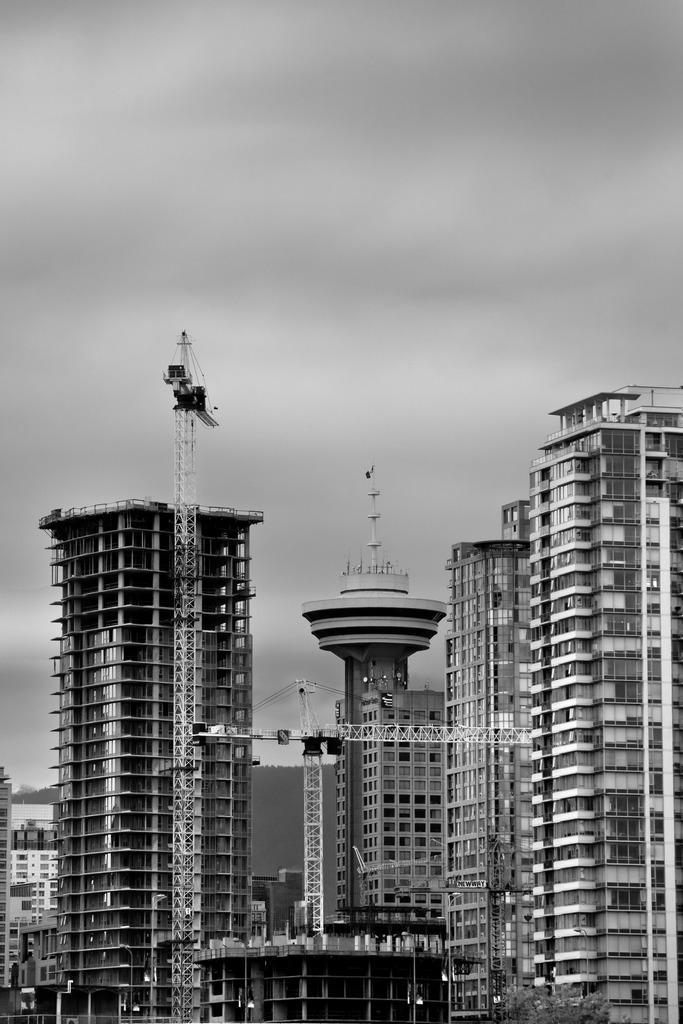Describe this image in one or two sentences. In this image I can see towers and at the top I can see the sky. 